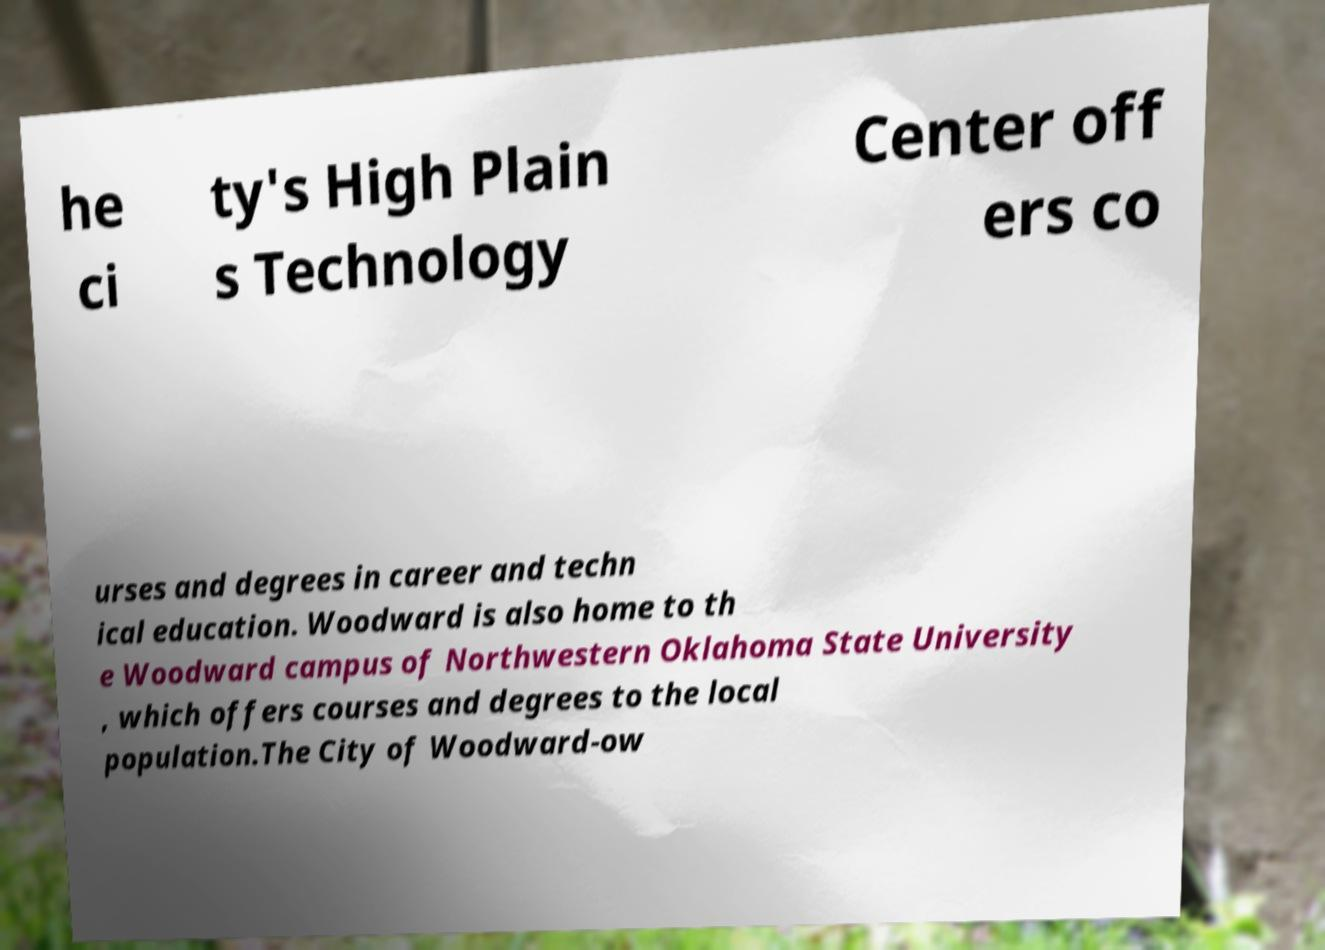I need the written content from this picture converted into text. Can you do that? he ci ty's High Plain s Technology Center off ers co urses and degrees in career and techn ical education. Woodward is also home to th e Woodward campus of Northwestern Oklahoma State University , which offers courses and degrees to the local population.The City of Woodward-ow 